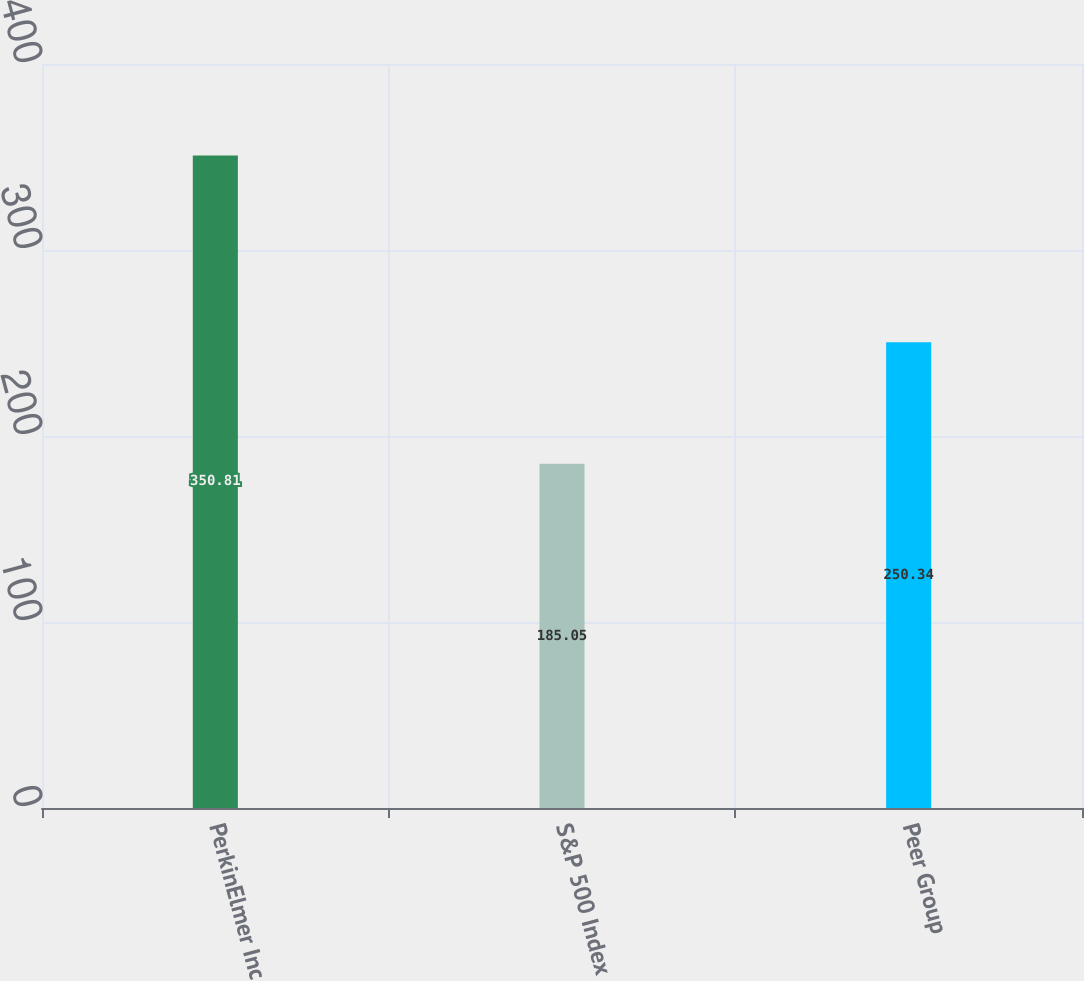Convert chart. <chart><loc_0><loc_0><loc_500><loc_500><bar_chart><fcel>PerkinElmer Inc<fcel>S&P 500 Index<fcel>Peer Group<nl><fcel>350.81<fcel>185.05<fcel>250.34<nl></chart> 